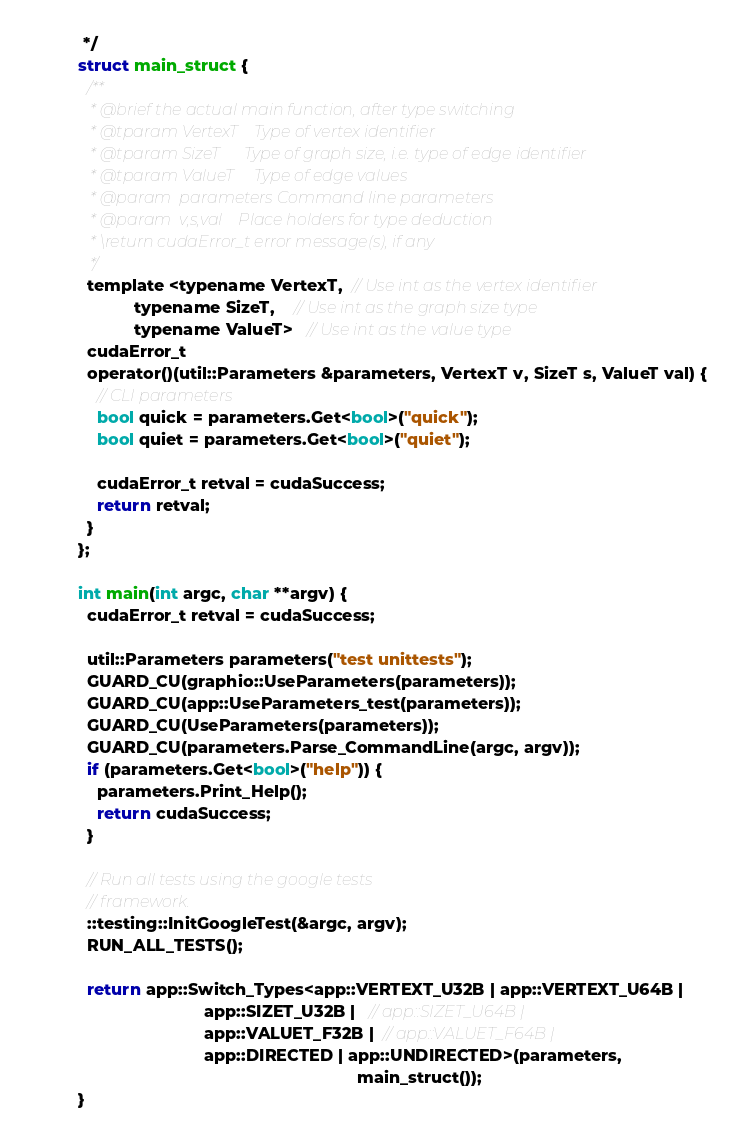<code> <loc_0><loc_0><loc_500><loc_500><_Cuda_> */
struct main_struct {
  /**
   * @brief the actual main function, after type switching
   * @tparam VertexT    Type of vertex identifier
   * @tparam SizeT      Type of graph size, i.e. type of edge identifier
   * @tparam ValueT     Type of edge values
   * @param  parameters Command line parameters
   * @param  v,s,val    Place holders for type deduction
   * \return cudaError_t error message(s), if any
   */
  template <typename VertexT,  // Use int as the vertex identifier
            typename SizeT,    // Use int as the graph size type
            typename ValueT>   // Use int as the value type
  cudaError_t
  operator()(util::Parameters &parameters, VertexT v, SizeT s, ValueT val) {
    // CLI parameters
    bool quick = parameters.Get<bool>("quick");
    bool quiet = parameters.Get<bool>("quiet");

    cudaError_t retval = cudaSuccess;
    return retval;
  }
};

int main(int argc, char **argv) {
  cudaError_t retval = cudaSuccess;

  util::Parameters parameters("test unittests");
  GUARD_CU(graphio::UseParameters(parameters));
  GUARD_CU(app::UseParameters_test(parameters));
  GUARD_CU(UseParameters(parameters));
  GUARD_CU(parameters.Parse_CommandLine(argc, argv));
  if (parameters.Get<bool>("help")) {
    parameters.Print_Help();
    return cudaSuccess;
  }

  // Run all tests using the google tests
  // framework.
  ::testing::InitGoogleTest(&argc, argv);
  RUN_ALL_TESTS();

  return app::Switch_Types<app::VERTEXT_U32B | app::VERTEXT_U64B |
                           app::SIZET_U32B |   // app::SIZET_U64B |
                           app::VALUET_F32B |  // app::VALUET_F64B |
                           app::DIRECTED | app::UNDIRECTED>(parameters,
                                                            main_struct());
}
</code> 